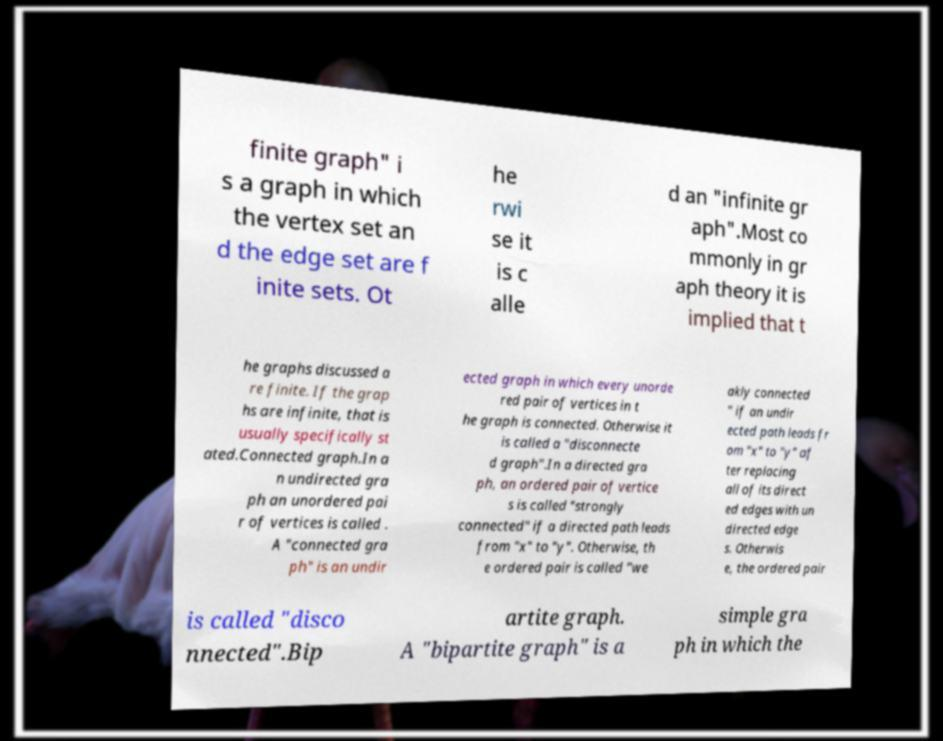Please read and relay the text visible in this image. What does it say? finite graph" i s a graph in which the vertex set an d the edge set are f inite sets. Ot he rwi se it is c alle d an "infinite gr aph".Most co mmonly in gr aph theory it is implied that t he graphs discussed a re finite. If the grap hs are infinite, that is usually specifically st ated.Connected graph.In a n undirected gra ph an unordered pai r of vertices is called . A "connected gra ph" is an undir ected graph in which every unorde red pair of vertices in t he graph is connected. Otherwise it is called a "disconnecte d graph".In a directed gra ph, an ordered pair of vertice s is called "strongly connected" if a directed path leads from "x" to "y". Otherwise, th e ordered pair is called "we akly connected " if an undir ected path leads fr om "x" to "y" af ter replacing all of its direct ed edges with un directed edge s. Otherwis e, the ordered pair is called "disco nnected".Bip artite graph. A "bipartite graph" is a simple gra ph in which the 